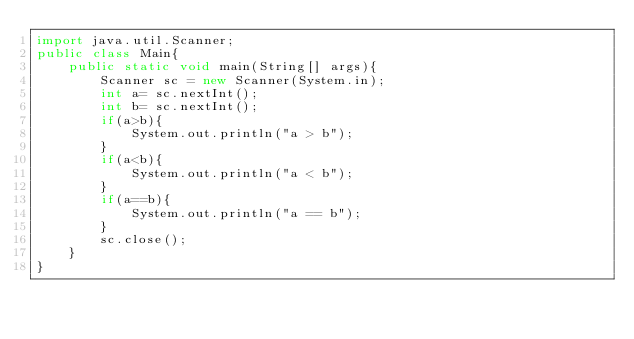Convert code to text. <code><loc_0><loc_0><loc_500><loc_500><_Java_>import java.util.Scanner;
public class Main{
    public static void main(String[] args){
        Scanner sc = new Scanner(System.in);
        int a= sc.nextInt();
        int b= sc.nextInt();
        if(a>b){
            System.out.println("a > b");
        }
        if(a<b){
            System.out.println("a < b");
        }
        if(a==b){
            System.out.println("a == b");
        }
        sc.close();
    }
}
</code> 